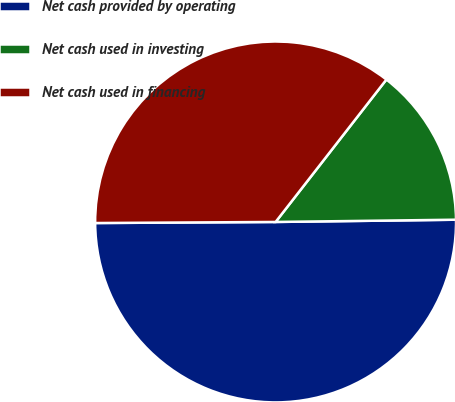Convert chart to OTSL. <chart><loc_0><loc_0><loc_500><loc_500><pie_chart><fcel>Net cash provided by operating<fcel>Net cash used in investing<fcel>Net cash used in financing<nl><fcel>50.11%<fcel>14.28%<fcel>35.62%<nl></chart> 